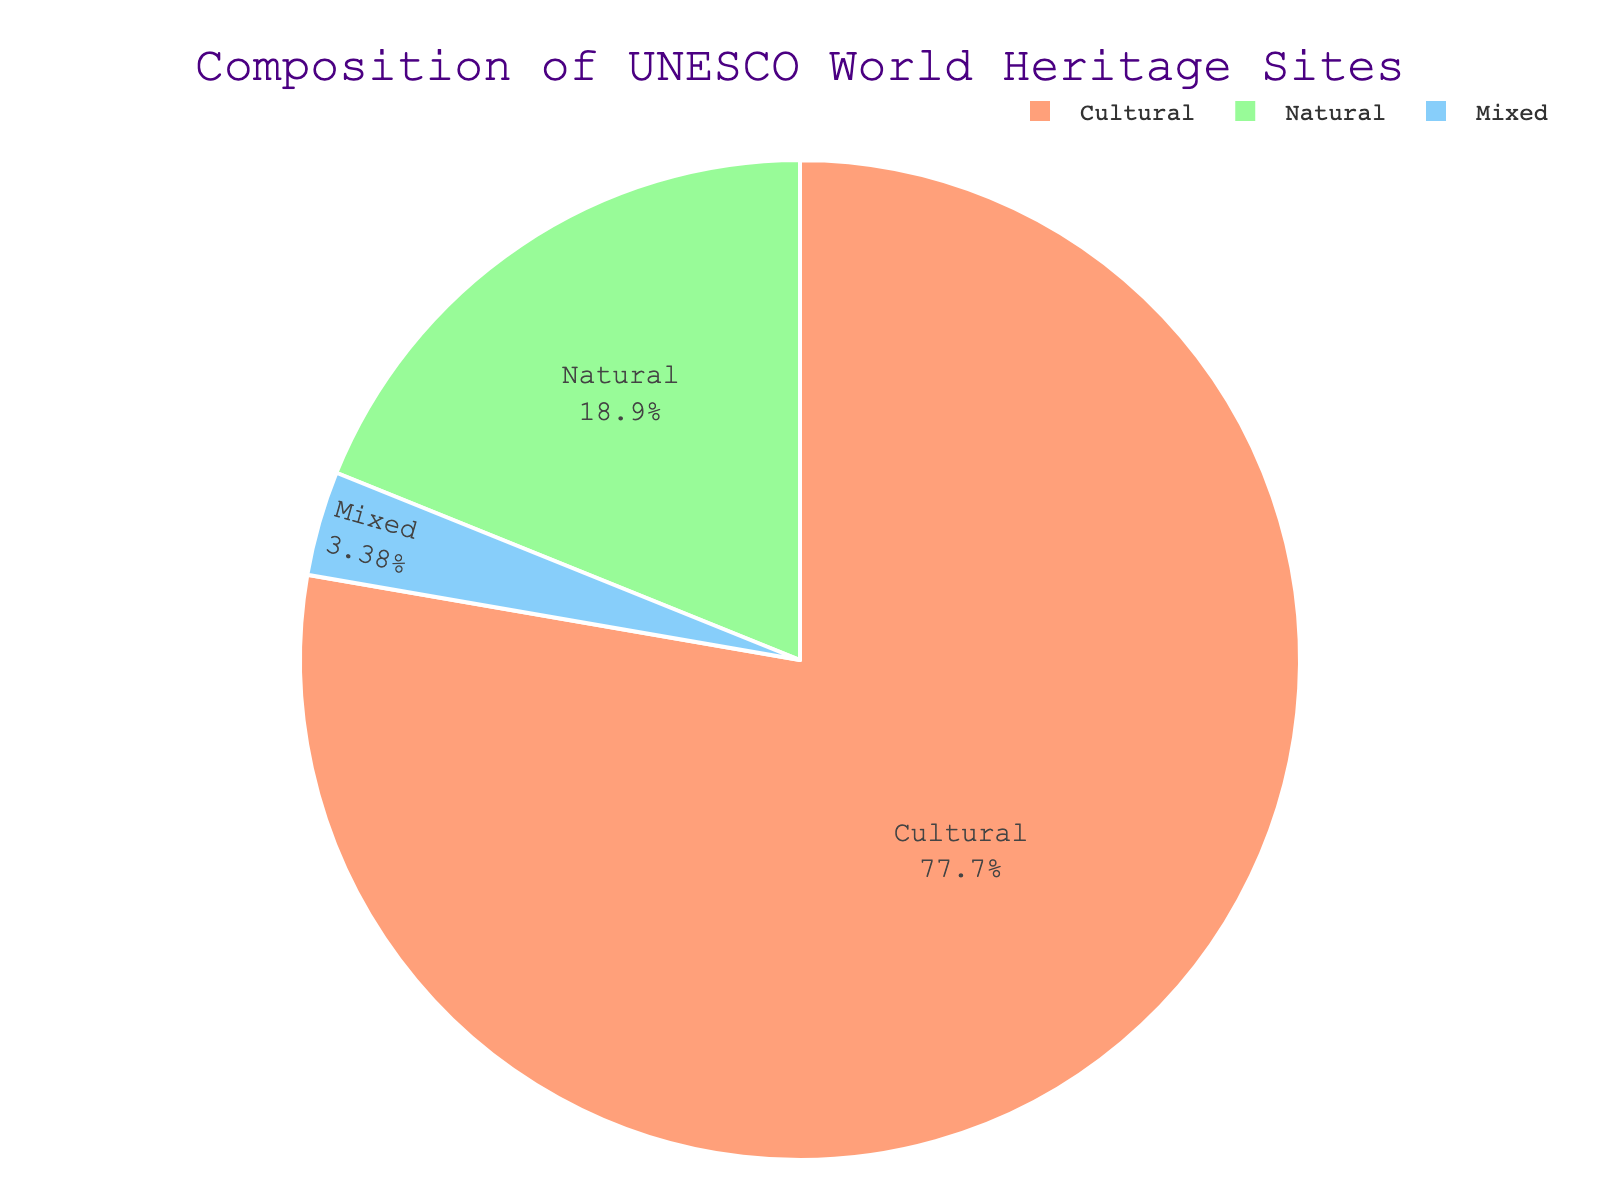What percentage of UNESCO World Heritage Sites are cultural? To find the percentage, divide the number of Cultural sites by the total number of sites, then multiply by 100. (897/1154) * 100 = 77.7%
Answer: 77.7% What is the difference in number between Cultural and Natural World Heritage Sites? Subtract the number of Natural sites from the number of Cultural sites. 897 - 218 = 679
Answer: 679 What is the combined number of Natural and Mixed World Heritage Sites? Add the number of Natural sites to the number of Mixed sites. 218 + 39 = 257
Answer: 257 Which type of UNESCO World Heritage Site has the smallest percentage? Look at the figure and identify the type with the smallest portion; this is the Mixed sites.
Answer: Mixed Are there more than twice as many Cultural sites as the combined number of Natural and Mixed sites? Calculate twice the combined number of Natural and Mixed sites first (2 * (218 + 39) = 514), and compare it with the number of Cultural sites. 897 > 514
Answer: Yes How many more sites does the largest category have compared to the category with the second largest number of sites? Identify the largest category (Cultural, 897) and the second largest (Natural, 218), then subtract the numbers. 897 - 218 = 679
Answer: 679 What are the colors used for the Cultural and Natural UNESCO World Heritage Sites in the chart? Based on the color palette described, Cultural is in a peach color and Natural is in a light green color.
Answer: Peach and light green What's the ratio of Cultural sites to Mixed sites? Divide the number of Cultural sites by the number of Mixed sites. 897 / 39 = 23
Answer: 23 Which type of site makes up approximately one-fifth of the total? To determine the type that is around one-fifth or 20%, divide each site's count by the total and check if any approximate 20%. (218/1154) is approximately 0.189, close to 0.20; hence, Natural sites.
Answer: Natural What is the percentage difference between Cultural and Mixed World Heritage Sites? Find the percentage difference using the formula: ((897 - 39) / 897) * 100 = 95.7%
Answer: 95.7% 